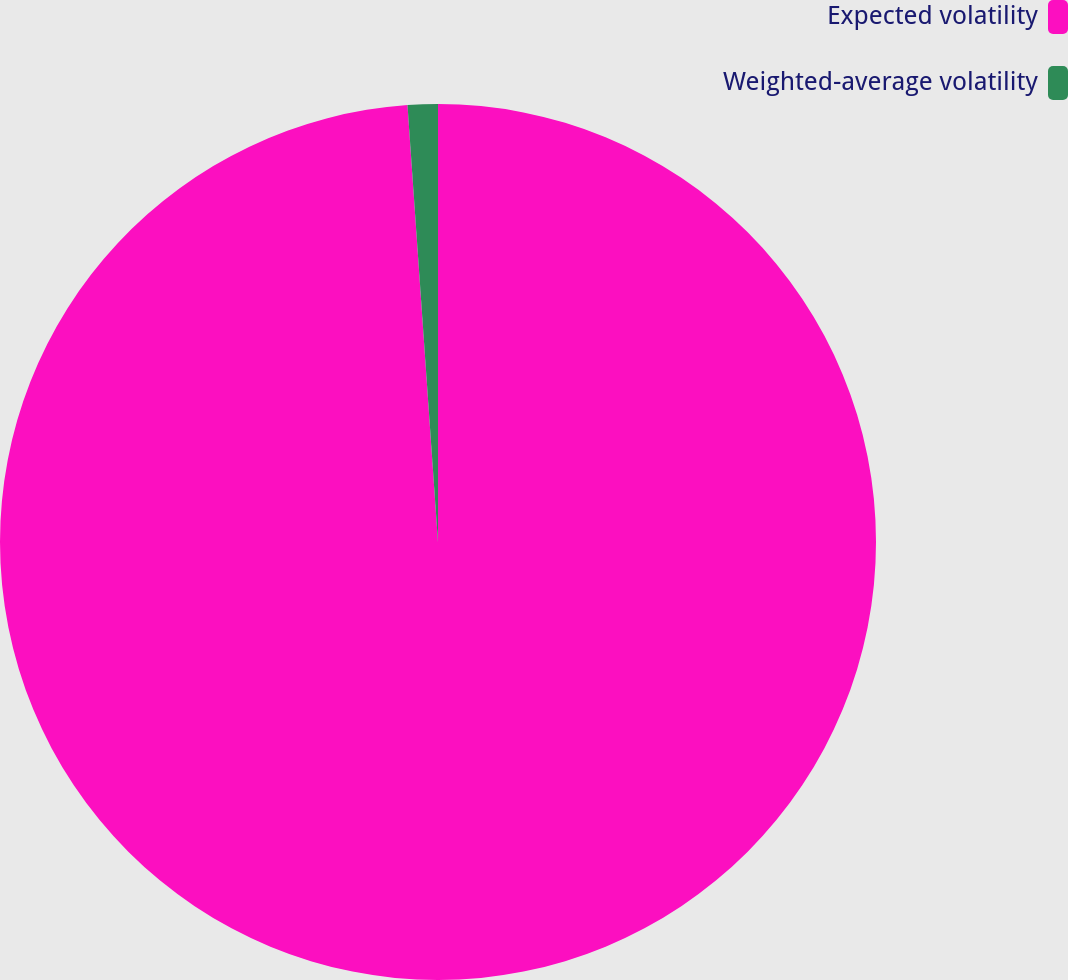Convert chart to OTSL. <chart><loc_0><loc_0><loc_500><loc_500><pie_chart><fcel>Expected volatility<fcel>Weighted-average volatility<nl><fcel>98.89%<fcel>1.11%<nl></chart> 